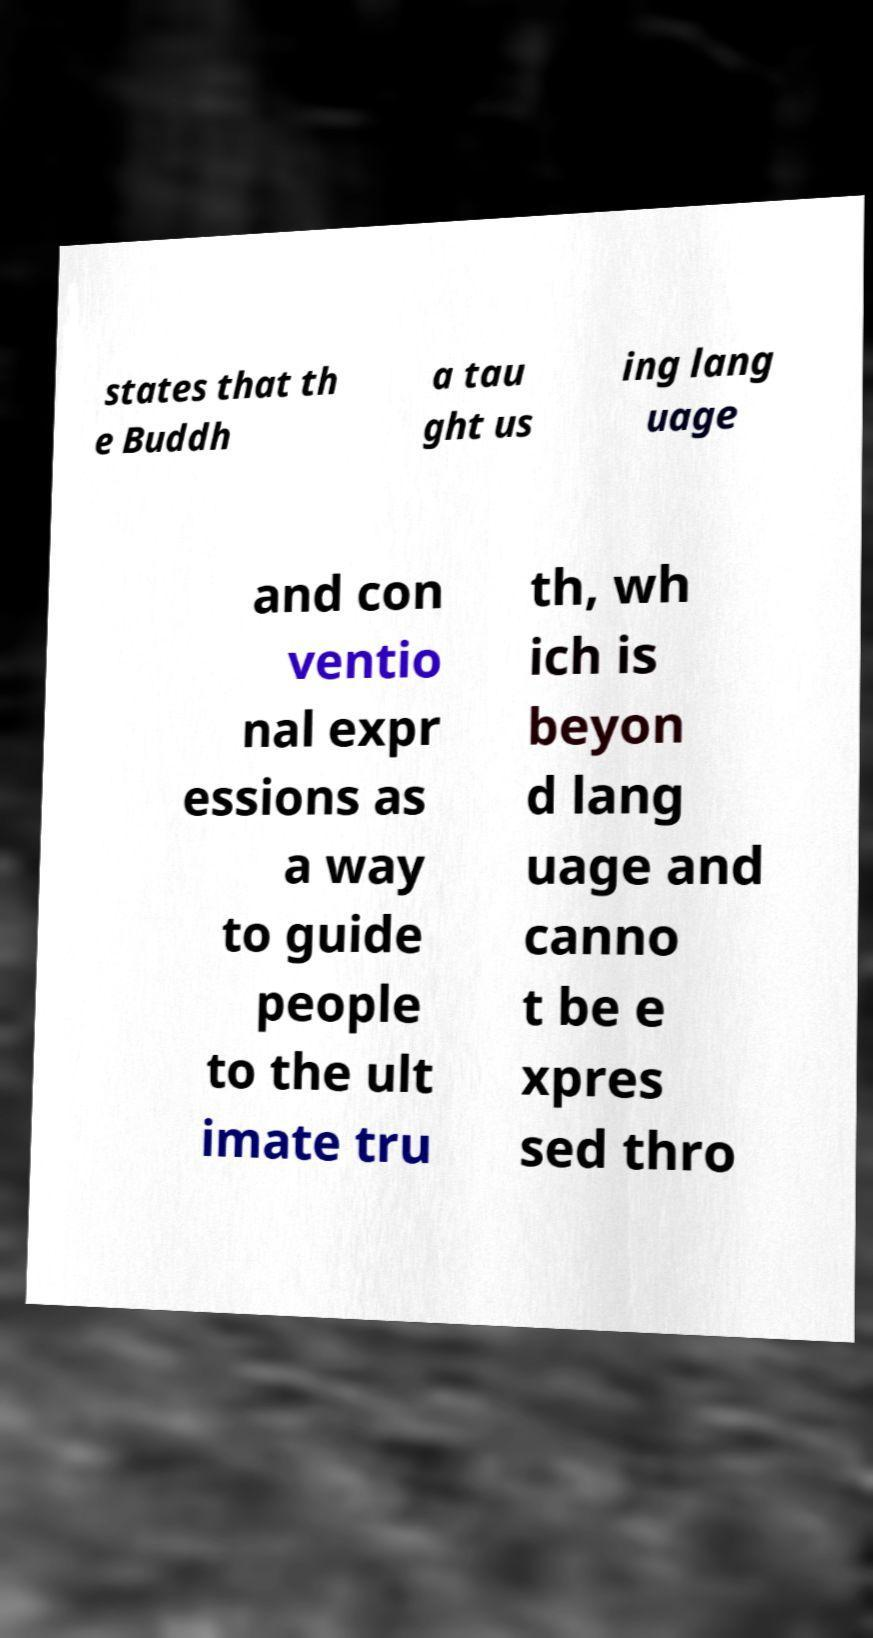I need the written content from this picture converted into text. Can you do that? states that th e Buddh a tau ght us ing lang uage and con ventio nal expr essions as a way to guide people to the ult imate tru th, wh ich is beyon d lang uage and canno t be e xpres sed thro 